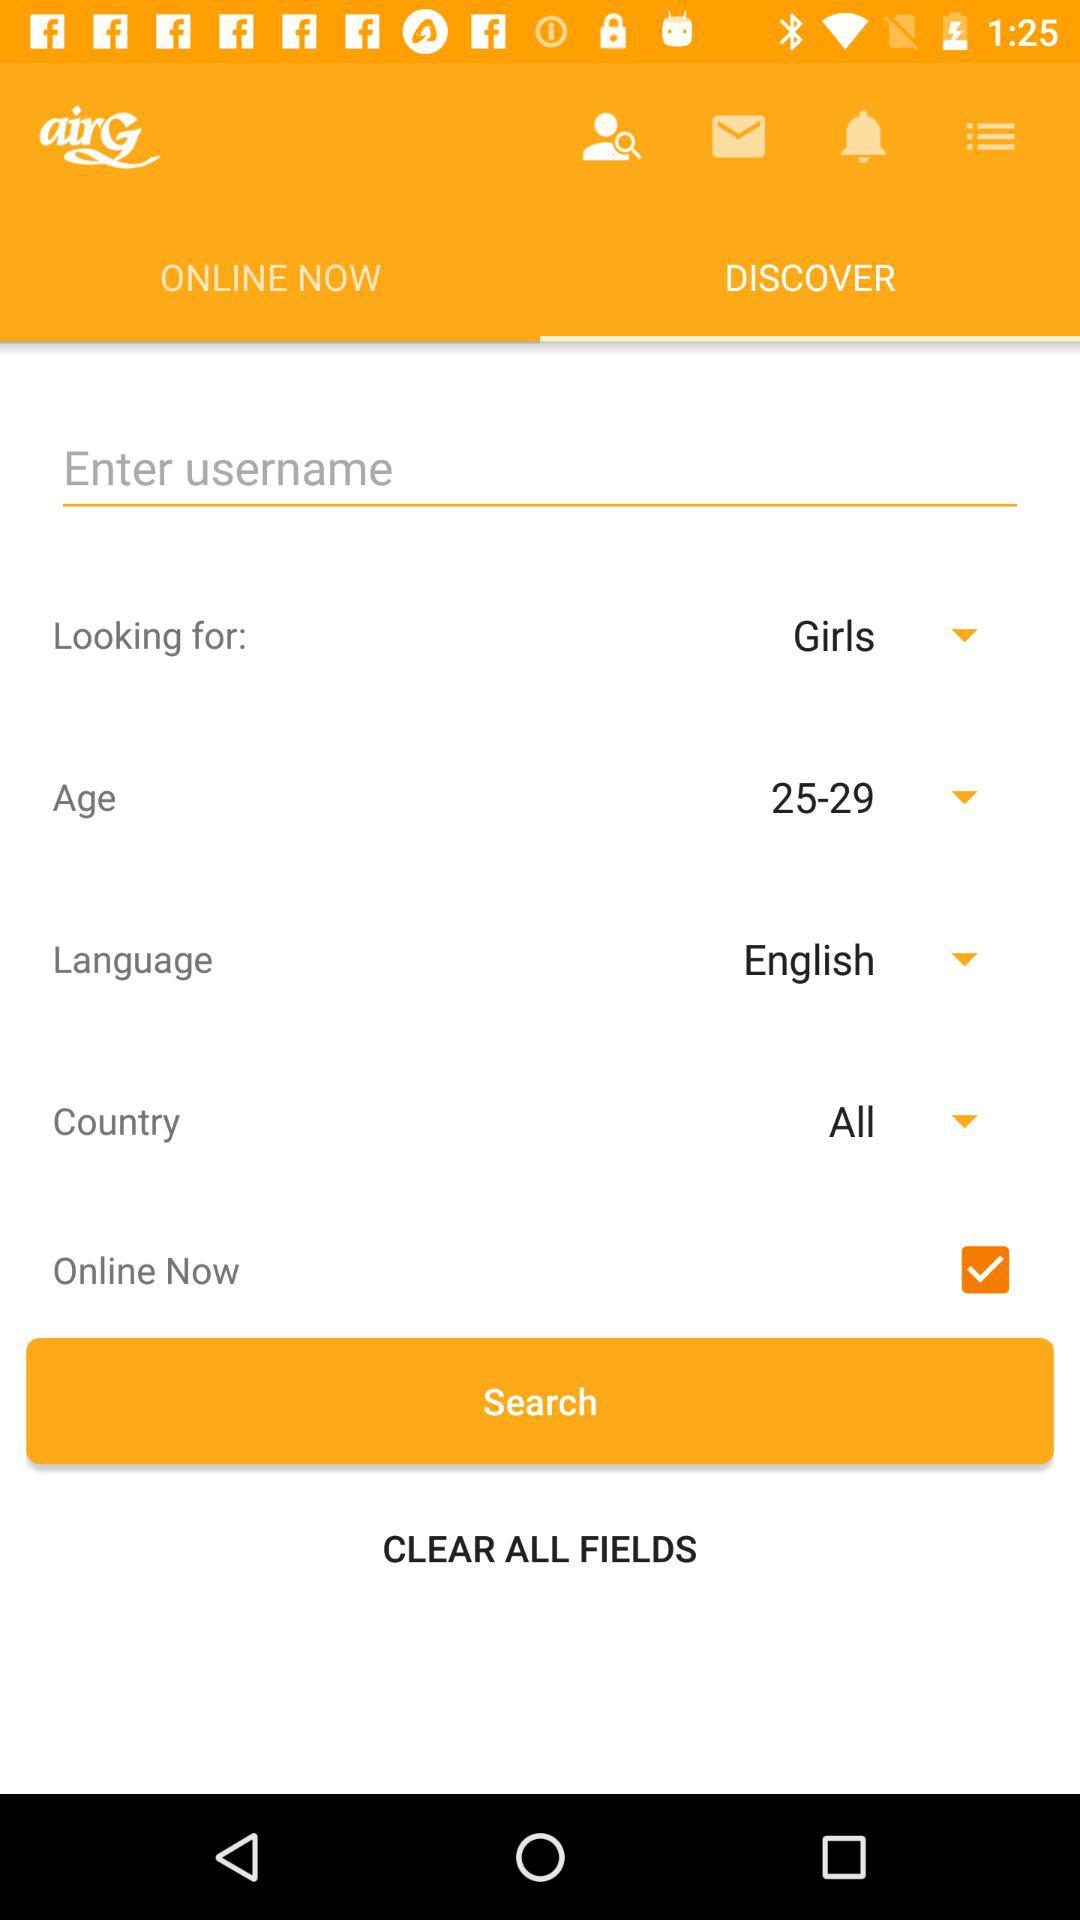What is the selected language? The selected language is English. 